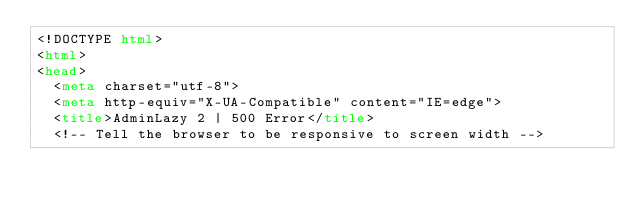<code> <loc_0><loc_0><loc_500><loc_500><_HTML_><!DOCTYPE html>
<html>
<head>
  <meta charset="utf-8">
  <meta http-equiv="X-UA-Compatible" content="IE=edge">
  <title>AdminLazy 2 | 500 Error</title>
  <!-- Tell the browser to be responsive to screen width --></code> 